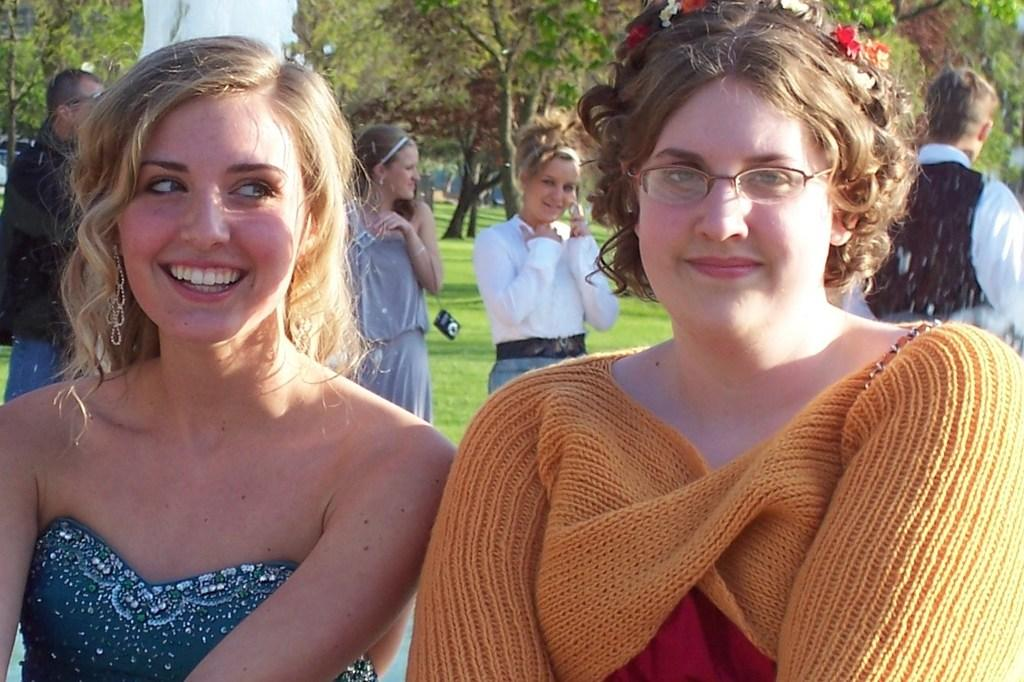What are the expressions of the people in the image? Two people are smiling in the image. Can you describe the woman's appearance? The woman is wearing spectacles. What can be seen in the background of the image? There is grass, trees, and people visible in the background of the image. What object is near one of the people? There is a camera near one of the people. What type of ticket is the woman holding in the image? There is no ticket present in the image; the woman is wearing spectacles and smiling. Can you tell me how the people are driving in the image? There is no driving activity depicted in the image; the people are standing and smiling. 